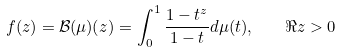Convert formula to latex. <formula><loc_0><loc_0><loc_500><loc_500>f ( z ) = \mathcal { B } ( \mu ) ( z ) = \int _ { 0 } ^ { 1 } \frac { 1 - t ^ { z } } { 1 - t } d \mu ( t ) , \quad \Re z > 0</formula> 